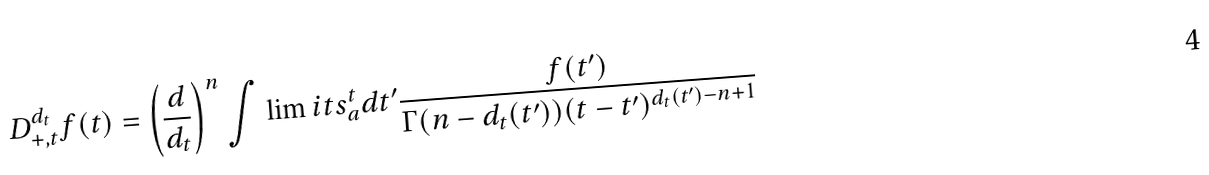Convert formula to latex. <formula><loc_0><loc_0><loc_500><loc_500>D _ { + , t } ^ { d _ { t } } f ( t ) = \left ( \frac { d } { d _ { t } } \right ) ^ { n } \int \lim i t s _ { a } ^ { t } { d t ^ { \prime } \frac { f ( t ^ { \prime } ) } { \Gamma ( n - d _ { t } ( t ^ { \prime } ) ) ( t - t ^ { \prime } ) ^ { d _ { t } ( t ^ { \prime } ) - n + 1 } } }</formula> 